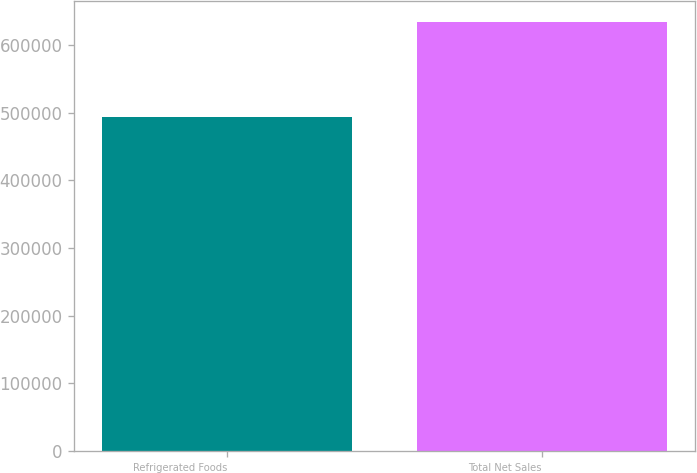Convert chart. <chart><loc_0><loc_0><loc_500><loc_500><bar_chart><fcel>Refrigerated Foods<fcel>Total Net Sales<nl><fcel>493618<fcel>633702<nl></chart> 